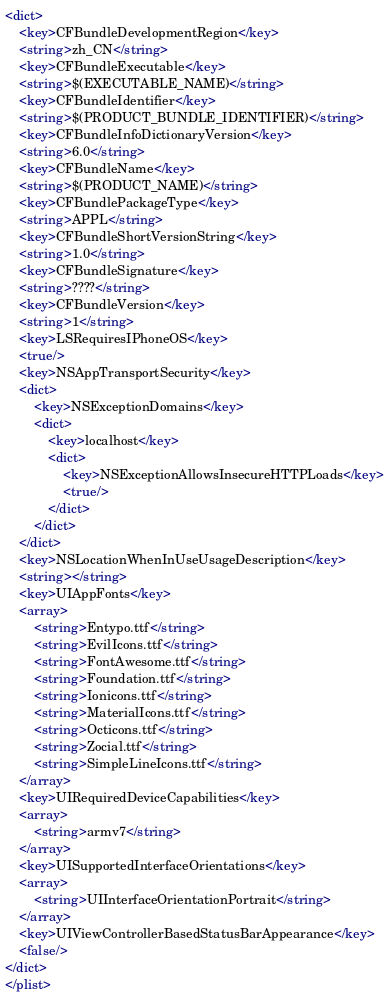<code> <loc_0><loc_0><loc_500><loc_500><_XML_><dict>
	<key>CFBundleDevelopmentRegion</key>
	<string>zh_CN</string>
	<key>CFBundleExecutable</key>
	<string>$(EXECUTABLE_NAME)</string>
	<key>CFBundleIdentifier</key>
	<string>$(PRODUCT_BUNDLE_IDENTIFIER)</string>
	<key>CFBundleInfoDictionaryVersion</key>
	<string>6.0</string>
	<key>CFBundleName</key>
	<string>$(PRODUCT_NAME)</string>
	<key>CFBundlePackageType</key>
	<string>APPL</string>
	<key>CFBundleShortVersionString</key>
	<string>1.0</string>
	<key>CFBundleSignature</key>
	<string>????</string>
	<key>CFBundleVersion</key>
	<string>1</string>
	<key>LSRequiresIPhoneOS</key>
	<true/>
	<key>NSAppTransportSecurity</key>
	<dict>
		<key>NSExceptionDomains</key>
		<dict>
			<key>localhost</key>
			<dict>
				<key>NSExceptionAllowsInsecureHTTPLoads</key>
				<true/>
			</dict>
		</dict>
	</dict>
	<key>NSLocationWhenInUseUsageDescription</key>
	<string></string>
	<key>UIAppFonts</key>
	<array>
		<string>Entypo.ttf</string>
		<string>EvilIcons.ttf</string>
		<string>FontAwesome.ttf</string>
		<string>Foundation.ttf</string>
		<string>Ionicons.ttf</string>
		<string>MaterialIcons.ttf</string>
		<string>Octicons.ttf</string>
		<string>Zocial.ttf</string>
		<string>SimpleLineIcons.ttf</string>
	</array>
	<key>UIRequiredDeviceCapabilities</key>
	<array>
		<string>armv7</string>
	</array>
	<key>UISupportedInterfaceOrientations</key>
	<array>
		<string>UIInterfaceOrientationPortrait</string>
	</array>
	<key>UIViewControllerBasedStatusBarAppearance</key>
	<false/>
</dict>
</plist>
</code> 